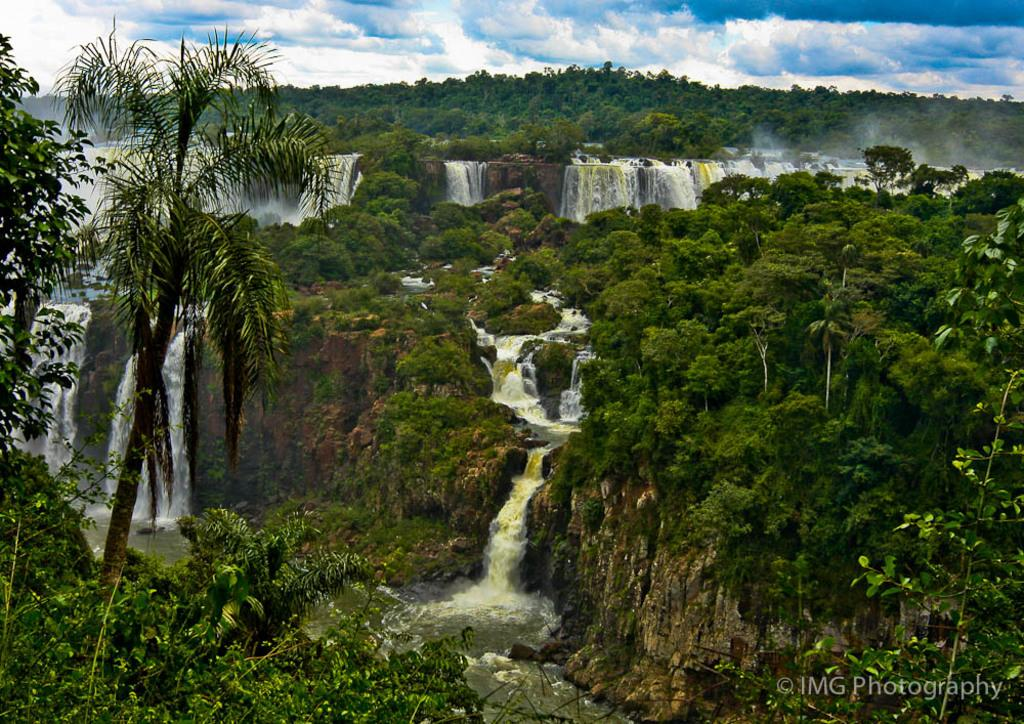What type of natural elements can be seen in the image? There are trees and water visible in the image. What else can be seen in the sky in the image? Clouds are present in the image. Is there any text or marking visible in the image? Yes, there is a watermark at the right bottom of the image. What type of drug is being used to comfort the person in the image? There is no person or drug present in the image; it features trees, water, and clouds. 